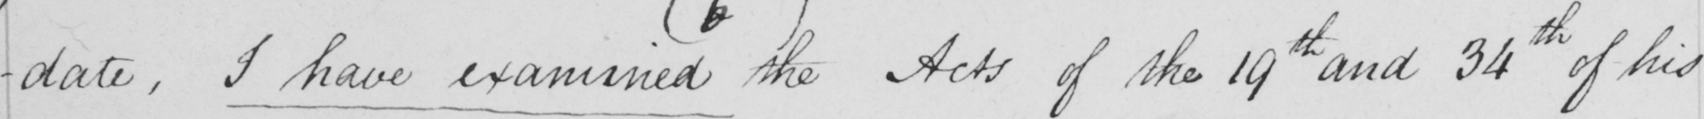Please provide the text content of this handwritten line. -date . I have examined  the Acts of the 19th and 34th of his 